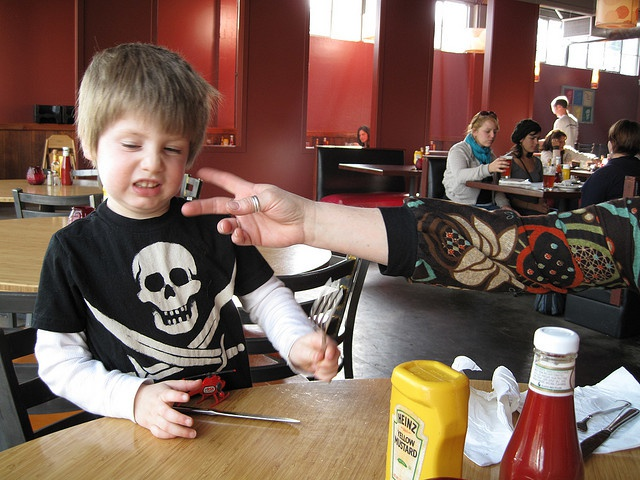Describe the objects in this image and their specific colors. I can see people in maroon, black, lightgray, darkgray, and gray tones, people in maroon, black, lightpink, and lightgray tones, dining table in maroon, tan, and olive tones, bottle in maroon, gold, olive, orange, and khaki tones, and bottle in maroon, brown, and lightgray tones in this image. 